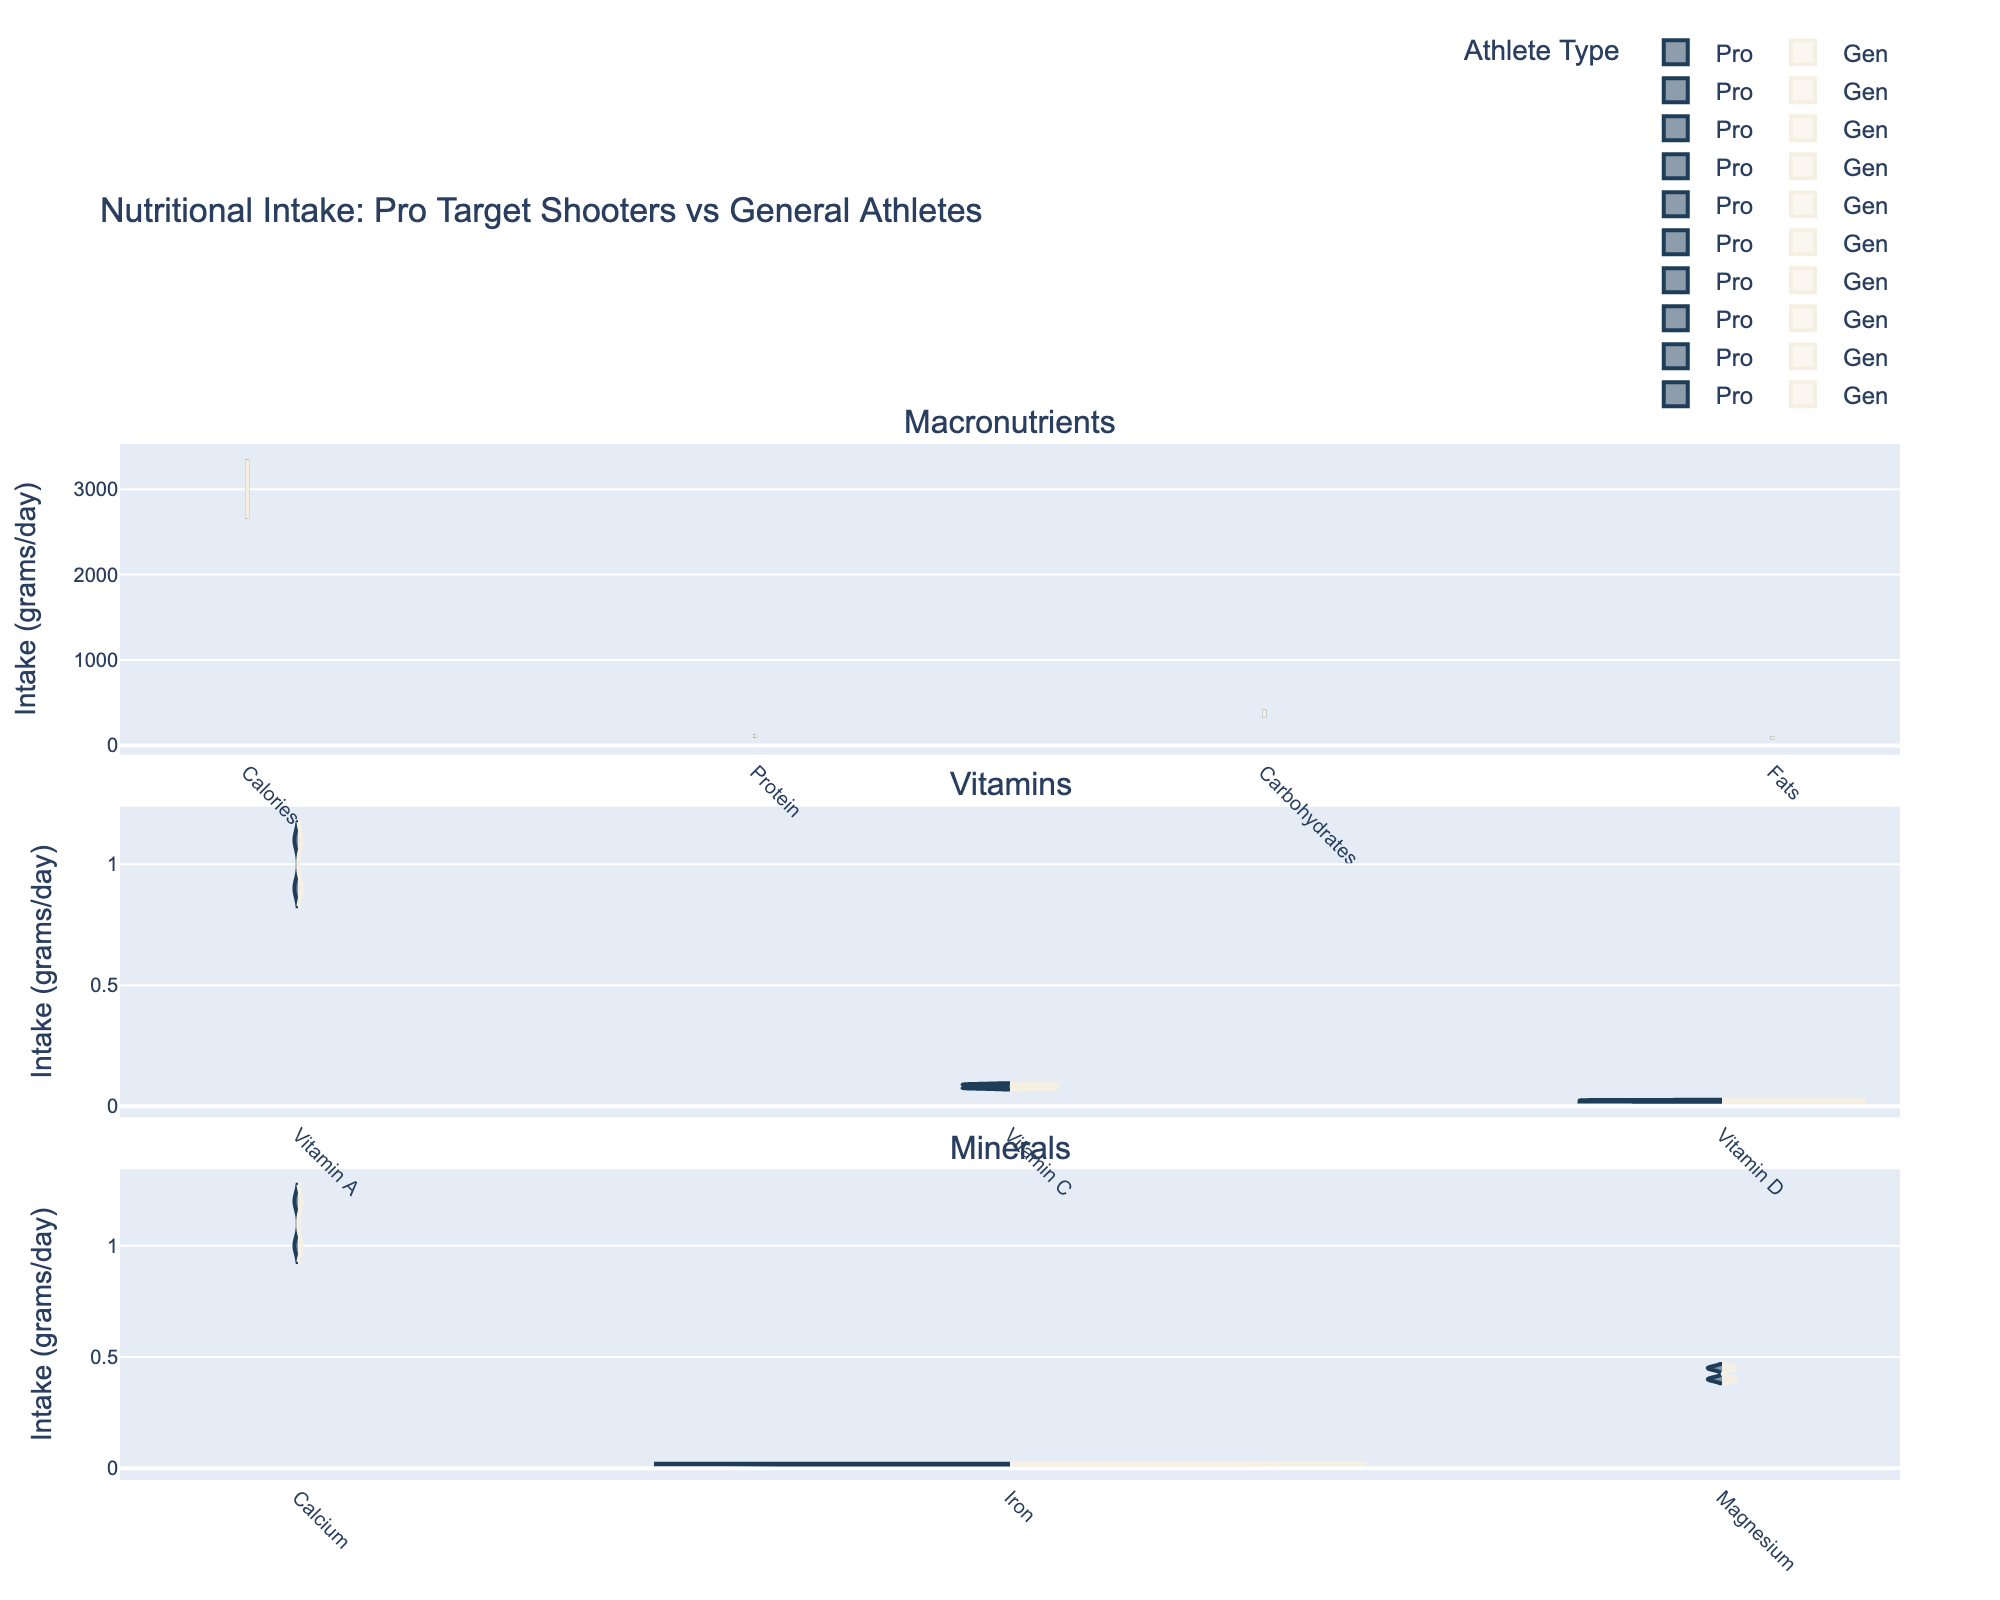What is the title of the chart? The title of a chart is usually found at the top and helps to summarize what the chart represents. In this figure, the title is located at the top.
Answer: Nutritional Intake: Pro Target Shooters vs General Athletes How many categories of nutrients are compared in the chart? Look at the labels of the subplots that divide the chart into different sections. Count the number of unique labels.
Answer: 3 Which group has higher calorie intake, professional target shooters or general athletes? Compare the left (professional target shooters) and right (general athletes) parts of the violin in the "Calories" section of the chart.
Answer: General athletes What is the difference in protein intake between professional target shooters and general athletes? Subtract the protein intake value of professional target shooters from that of general athletes. The intake values can be read from the corresponding violins in the "Protein" section of the chart.
Answer: 20 grams/day Which nutrient has the smallest difference in intake between professional target shooters and general athletes? Compare the differences for each nutrient by looking at the two halves of each violin plot, identifying the one with the smallest visual gap or difference.
Answer: Iron Are there any nutrients where the intake is higher for professional target shooters than general athletes? Examine the direction of the violin plots; if the left side (professional target shooters) is higher for any nutrient, it indicates more intake for target shooters.
Answer: No What mineral content do professional target shooters intake more of compared to general athletes? Compare the left and right parts of the violins in the "Minerals" category. None should show the left side (professional target shooters) being higher.
Answer: None Which group has a wider range of nutrient intake, based on the violin plot shapes? The width of the violin plot at various points reflects the density and distribution of values. Compare the overall width of violins for both groups.
Answer: General athletes What is the most distinct difference in nutritional intake between the two groups? Look at all the violin plots and identify the one with the most visible difference in height between the left and right halves.
Answer: Calories 